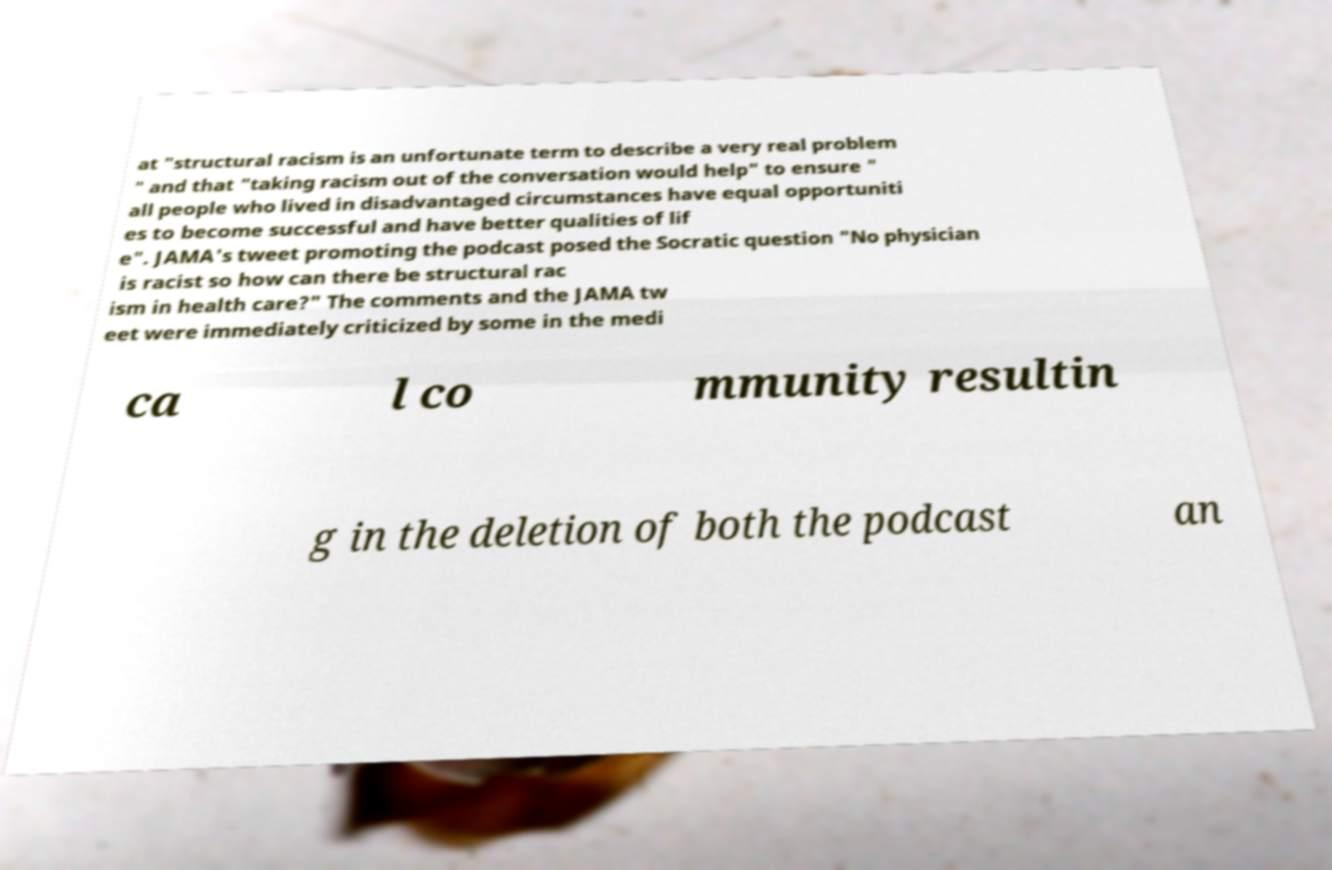What messages or text are displayed in this image? I need them in a readable, typed format. at "structural racism is an unfortunate term to describe a very real problem " and that "taking racism out of the conversation would help" to ensure " all people who lived in disadvantaged circumstances have equal opportuniti es to become successful and have better qualities of lif e". JAMA's tweet promoting the podcast posed the Socratic question "No physician is racist so how can there be structural rac ism in health care?" The comments and the JAMA tw eet were immediately criticized by some in the medi ca l co mmunity resultin g in the deletion of both the podcast an 